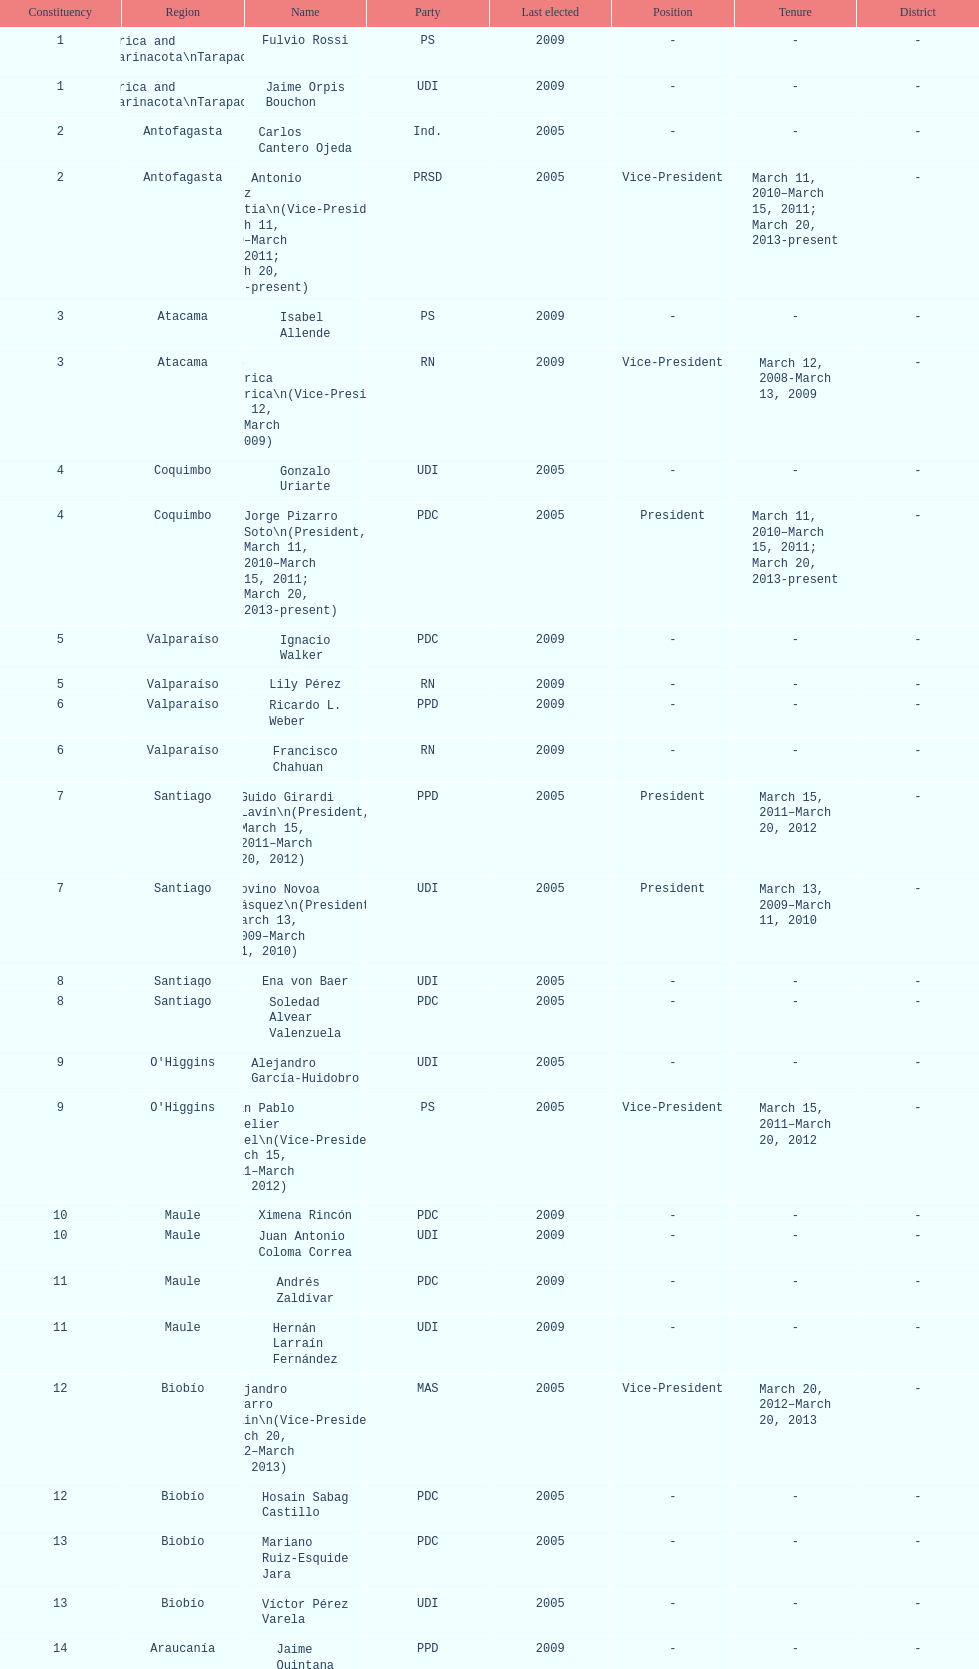How many total consituency are listed in the table? 19. Write the full table. {'header': ['Constituency', 'Region', 'Name', 'Party', 'Last elected', 'Position', 'Tenure', 'District'], 'rows': [['1', 'Arica and Parinacota\\nTarapacá', 'Fulvio Rossi', 'PS', '2009', '-', '-', '-'], ['1', 'Arica and Parinacota\\nTarapacá', 'Jaime Orpis Bouchon', 'UDI', '2009', '-', '-', '-'], ['2', 'Antofagasta', 'Carlos Cantero Ojeda', 'Ind.', '2005', '-', '-', '-'], ['2', 'Antofagasta', 'José Antonio Gómez Urrutia\\n(Vice-President, March 11, 2010–March 15, 2011; March 20, 2013-present)', 'PRSD', '2005', 'Vice-President', 'March 11, 2010–March 15, 2011; March 20, 2013-present', '-'], ['3', 'Atacama', 'Isabel Allende', 'PS', '2009', '-', '-', '-'], ['3', 'Atacama', 'Baldo Prokurica Prokurica\\n(Vice-President, March 12, 2008-March 13, 2009)', 'RN', '2009', 'Vice-President', 'March 12, 2008-March 13, 2009', '-'], ['4', 'Coquimbo', 'Gonzalo Uriarte', 'UDI', '2005', '-', '-', '-'], ['4', 'Coquimbo', 'Jorge Pizarro Soto\\n(President, March 11, 2010–March 15, 2011; March 20, 2013-present)', 'PDC', '2005', 'President', 'March 11, 2010–March 15, 2011; March 20, 2013-present', '-'], ['5', 'Valparaíso', 'Ignacio Walker', 'PDC', '2009', '-', '-', '-'], ['5', 'Valparaíso', 'Lily Pérez', 'RN', '2009', '-', '-', '-'], ['6', 'Valparaíso', 'Ricardo L. Weber', 'PPD', '2009', '-', '-', '-'], ['6', 'Valparaíso', 'Francisco Chahuan', 'RN', '2009', '-', '-', '-'], ['7', 'Santiago', 'Guido Girardi Lavín\\n(President, March 15, 2011–March 20, 2012)', 'PPD', '2005', 'President', 'March 15, 2011–March 20, 2012', '-'], ['7', 'Santiago', 'Jovino Novoa Vásquez\\n(President, March 13, 2009–March 11, 2010)', 'UDI', '2005', 'President', 'March 13, 2009–March 11, 2010', '-'], ['8', 'Santiago', 'Ena von Baer', 'UDI', '2005', '-', '-', '-'], ['8', 'Santiago', 'Soledad Alvear Valenzuela', 'PDC', '2005', '-', '-', '-'], ['9', "O'Higgins", 'Alejandro García-Huidobro', 'UDI', '2005', '-', '-', '-'], ['9', "O'Higgins", 'Juan Pablo Letelier Morel\\n(Vice-President, March 15, 2011–March 20, 2012)', 'PS', '2005', 'Vice-President', 'March 15, 2011–March 20, 2012', '-'], ['10', 'Maule', 'Ximena Rincón', 'PDC', '2009', '-', '-', '-'], ['10', 'Maule', 'Juan Antonio Coloma Correa', 'UDI', '2009', '-', '-', '-'], ['11', 'Maule', 'Andrés Zaldívar', 'PDC', '2009', '-', '-', '-'], ['11', 'Maule', 'Hernán Larraín Fernández', 'UDI', '2009', '-', '-', '-'], ['12', 'Biobío', 'Alejandro Navarro Brain\\n(Vice-President, March 20, 2012–March 20, 2013)', 'MAS', '2005', 'Vice-President', 'March 20, 2012–March 20, 2013', '-'], ['12', 'Biobío', 'Hosain Sabag Castillo', 'PDC', '2005', '-', '-', '-'], ['13', 'Biobío', 'Mariano Ruiz-Esquide Jara', 'PDC', '2005', '-', '-', '-'], ['13', 'Biobío', 'Víctor Pérez Varela', 'UDI', '2005', '-', '-', '-'], ['14', 'Araucanía', 'Jaime Quintana', 'PPD', '2009', '-', '-', '-'], ['14', 'Araucanía', 'Alberto Espina Otero', 'RN', '2009', '-', '-', '-'], ['15', 'Araucanía', 'Eugenio Tuma', 'PPD', '2009', '-', '-', '-'], ['15', 'Araucanía', 'José García Ruminot', 'RN', '2009', '-', '-', '-'], ['16', 'Los Ríos\\n(plus District 55)', 'Carlos Larraín Peña', 'RN', '2005', '-', '-', '55'], ['16', 'Los Ríos\\n(plus District 55)', 'Eduardo Frei Ruiz-Tagle\\n(President, March 11, 2006-March 12, 2008)', 'PDC', '2005', 'President', 'March 11, 2006-March 12, 2008', '55'], ['17', 'Los Lagos\\n(minus District 55)', 'Camilo Escalona Medina\\n(President, March 20, 2012–March 20, 2013)', 'PS', '2005', 'President', 'March 20, 2012–March 20, 2013', '-'], ['17', 'Los Lagos\\n(minus District 55)', 'Carlos Kuschel Silva', 'RN', '2005', '-', '-', '-'], ['18', 'Aisén', 'Patricio Walker', 'PDC', '2009', '-', '-', '-'], ['18', 'Aisén', 'Antonio Horvath Kiss', 'RN', '2001', '-', '-', '-'], ['19', 'Magallanes', 'Carlos Bianchi Chelech\\n(Vice-President, March 13, 2009–March 11, 2010)', 'Ind.', '2005', 'Vice-President', 'March 13, 2009–March 11, 2010', '-'], ['19', 'Magallanes', 'Pedro Muñoz Aburto', 'PS', '2005', '-', '-', '-']]} 